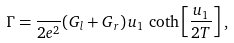Convert formula to latex. <formula><loc_0><loc_0><loc_500><loc_500>\Gamma = \frac { } { 2 e ^ { 2 } } ( G _ { l } + G _ { r } ) \, u _ { 1 } \, \coth \left [ \frac { u _ { 1 } } { 2 T } \right ] ,</formula> 